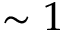Convert formula to latex. <formula><loc_0><loc_0><loc_500><loc_500>\sim 1</formula> 